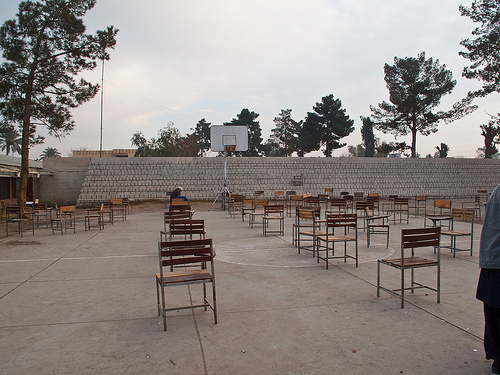<image>
Is there a basket behind the court? No. The basket is not behind the court. From this viewpoint, the basket appears to be positioned elsewhere in the scene. 